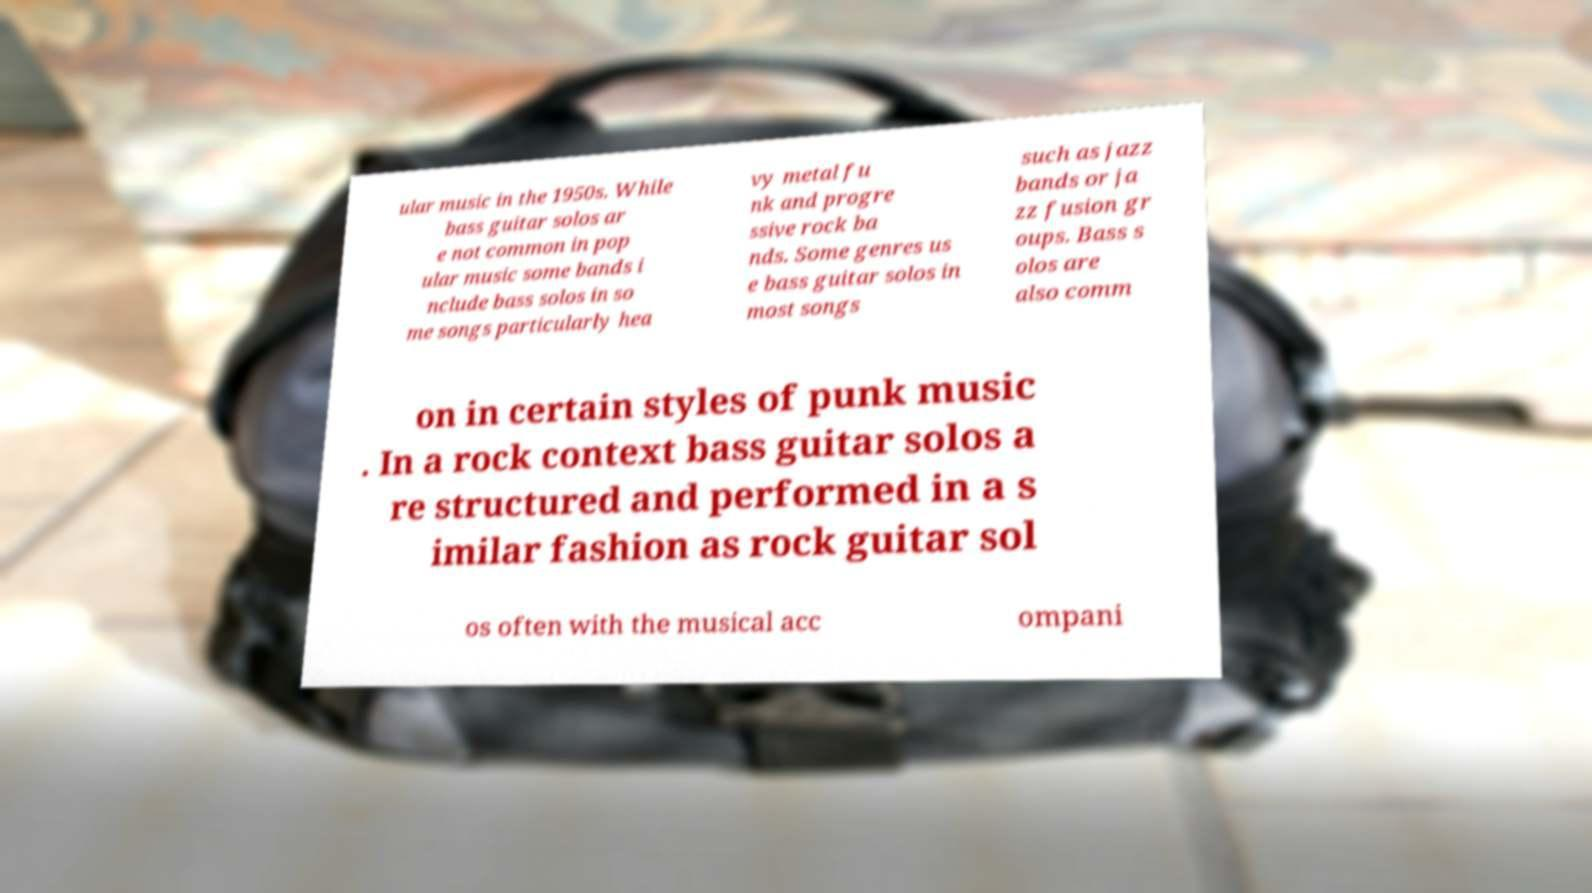I need the written content from this picture converted into text. Can you do that? ular music in the 1950s. While bass guitar solos ar e not common in pop ular music some bands i nclude bass solos in so me songs particularly hea vy metal fu nk and progre ssive rock ba nds. Some genres us e bass guitar solos in most songs such as jazz bands or ja zz fusion gr oups. Bass s olos are also comm on in certain styles of punk music . In a rock context bass guitar solos a re structured and performed in a s imilar fashion as rock guitar sol os often with the musical acc ompani 